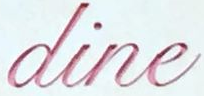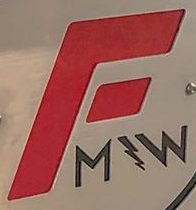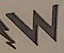What words are shown in these images in order, separated by a semicolon? dine; F; W 